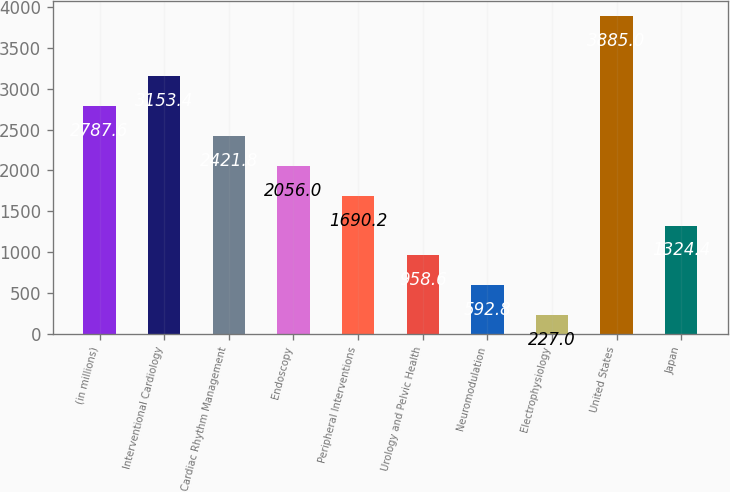Convert chart to OTSL. <chart><loc_0><loc_0><loc_500><loc_500><bar_chart><fcel>(in millions)<fcel>Interventional Cardiology<fcel>Cardiac Rhythm Management<fcel>Endoscopy<fcel>Peripheral Interventions<fcel>Urology and Pelvic Health<fcel>Neuromodulation<fcel>Electrophysiology<fcel>United States<fcel>Japan<nl><fcel>2787.6<fcel>3153.4<fcel>2421.8<fcel>2056<fcel>1690.2<fcel>958.6<fcel>592.8<fcel>227<fcel>3885<fcel>1324.4<nl></chart> 